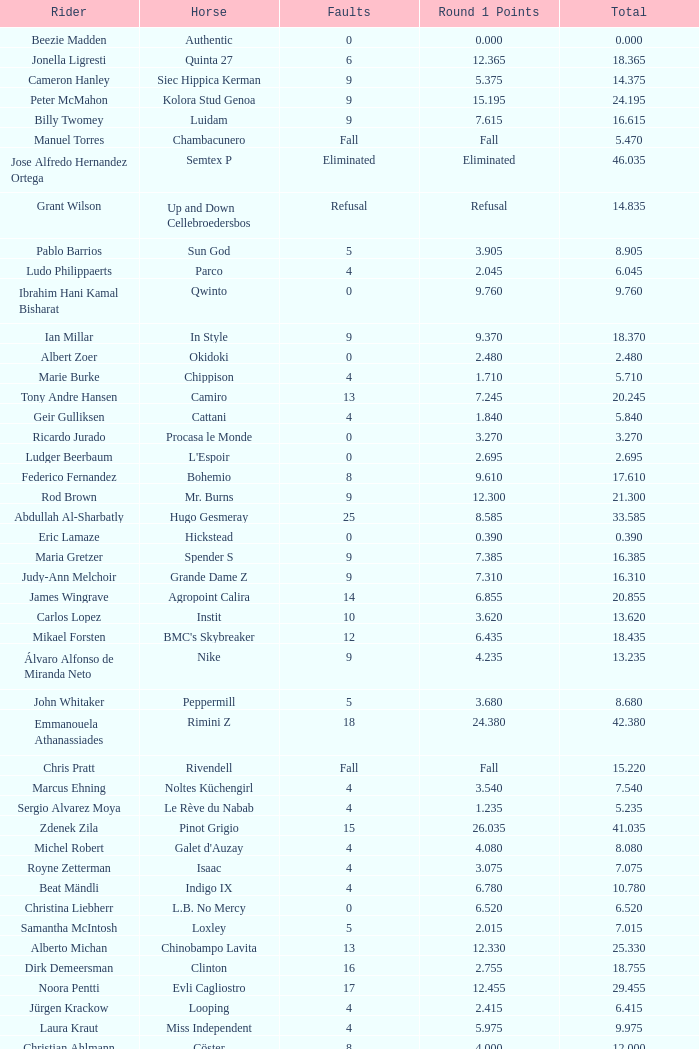Tell me the most total for horse of carlson 29.545. 